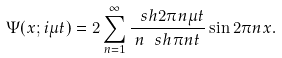<formula> <loc_0><loc_0><loc_500><loc_500>\Psi ( x ; i \mu t ) = 2 \sum _ { n = 1 } ^ { \infty } \frac { \ s h 2 \pi n \mu t } { n \ s h \pi n t } \sin 2 \pi n x .</formula> 